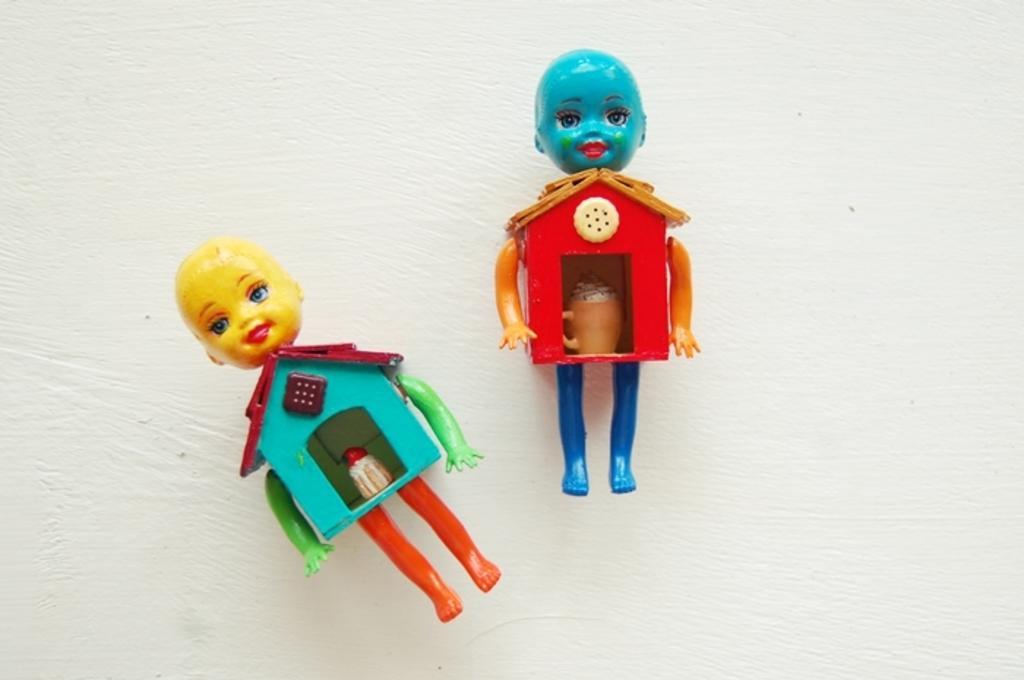Could you give a brief overview of what you see in this image? In this image we can see two toys on the white color surface. 